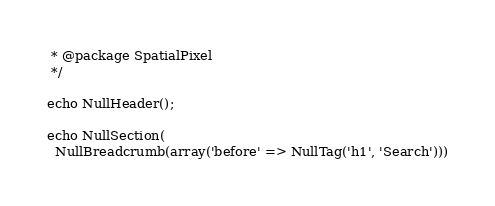<code> <loc_0><loc_0><loc_500><loc_500><_PHP_> * @package SpatialPixel
 */

echo NullHeader();

echo NullSection(
  NullBreadcrumb(array('before' => NullTag('h1', 'Search')))</code> 